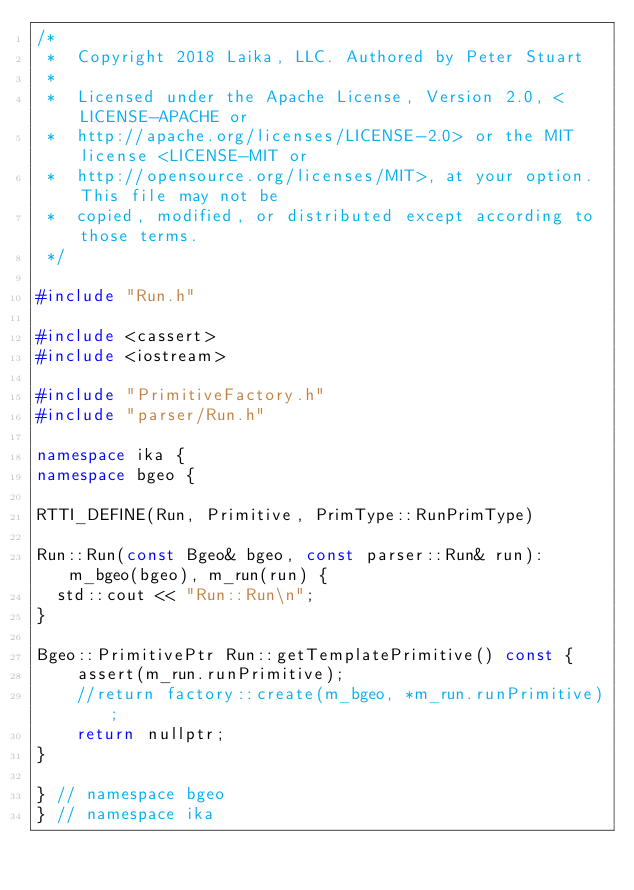<code> <loc_0><loc_0><loc_500><loc_500><_C++_>/*
 *  Copyright 2018 Laika, LLC. Authored by Peter Stuart
 *
 *  Licensed under the Apache License, Version 2.0, <LICENSE-APACHE or
 *  http://apache.org/licenses/LICENSE-2.0> or the MIT license <LICENSE-MIT or
 *  http://opensource.org/licenses/MIT>, at your option. This file may not be
 *  copied, modified, or distributed except according to those terms.
 */

#include "Run.h"

#include <cassert>
#include <iostream>

#include "PrimitiveFactory.h"
#include "parser/Run.h"

namespace ika {
namespace bgeo {

RTTI_DEFINE(Run, Primitive, PrimType::RunPrimType)

Run::Run(const Bgeo& bgeo, const parser::Run& run): m_bgeo(bgeo), m_run(run) { 
	std::cout << "Run::Run\n";
}

Bgeo::PrimitivePtr Run::getTemplatePrimitive() const {
    assert(m_run.runPrimitive);
    //return factory::create(m_bgeo, *m_run.runPrimitive);
    return nullptr;
}

} // namespace bgeo
} // namespace ika
</code> 